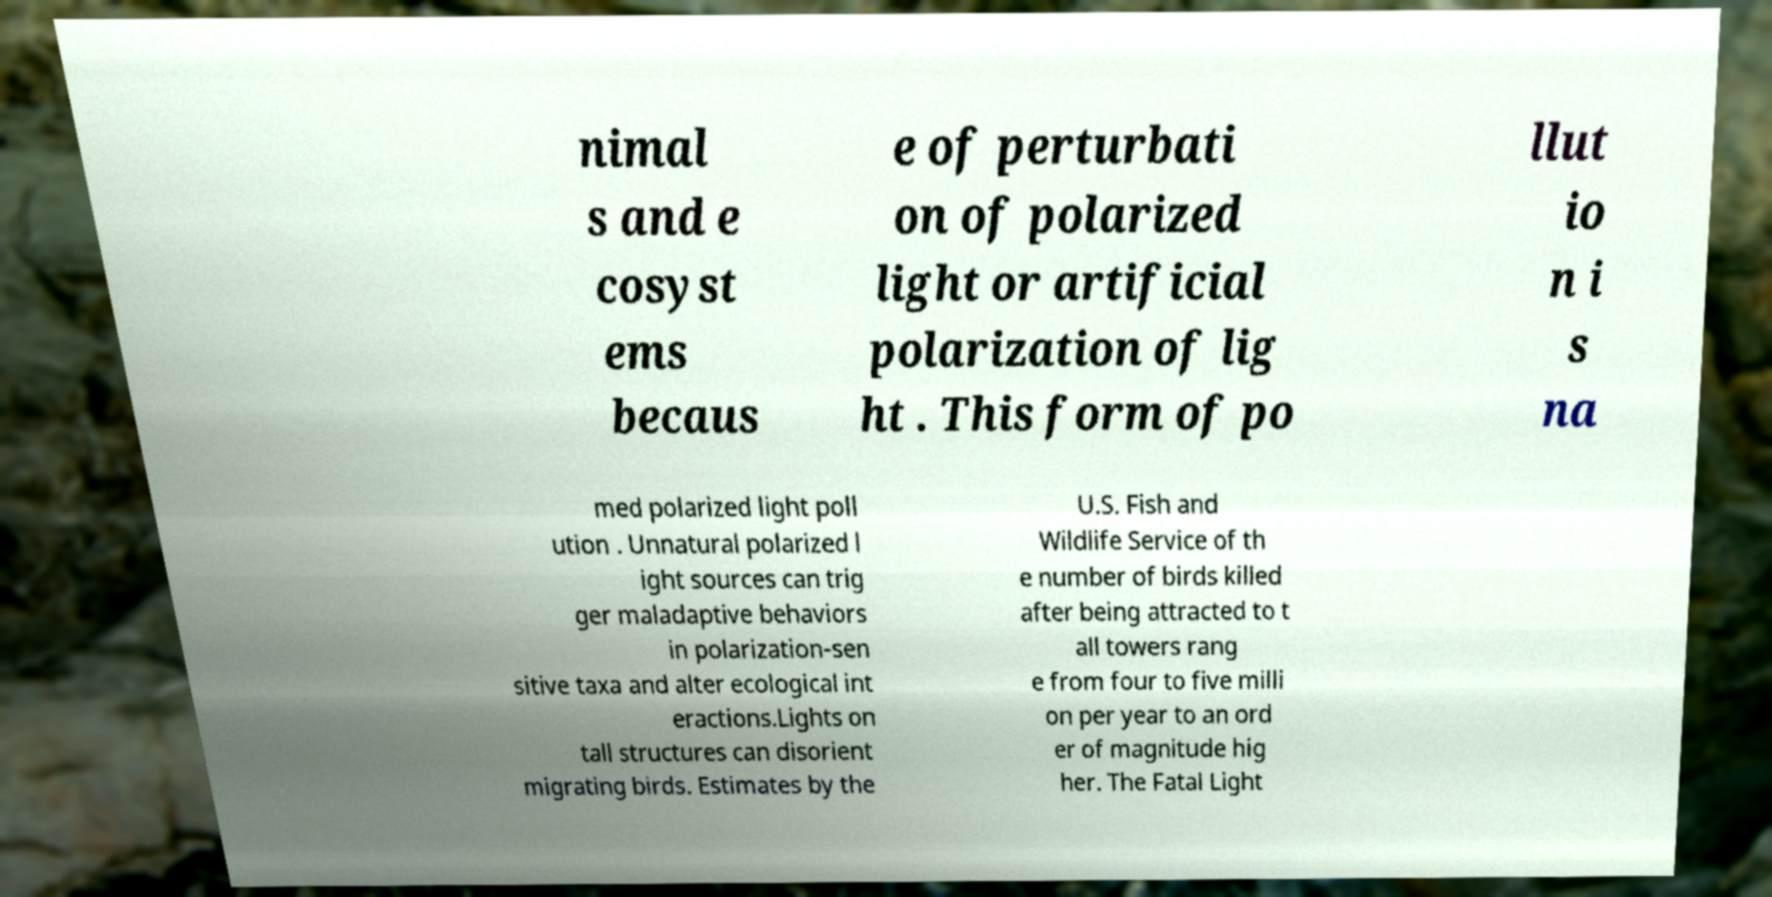Could you assist in decoding the text presented in this image and type it out clearly? nimal s and e cosyst ems becaus e of perturbati on of polarized light or artificial polarization of lig ht . This form of po llut io n i s na med polarized light poll ution . Unnatural polarized l ight sources can trig ger maladaptive behaviors in polarization-sen sitive taxa and alter ecological int eractions.Lights on tall structures can disorient migrating birds. Estimates by the U.S. Fish and Wildlife Service of th e number of birds killed after being attracted to t all towers rang e from four to five milli on per year to an ord er of magnitude hig her. The Fatal Light 